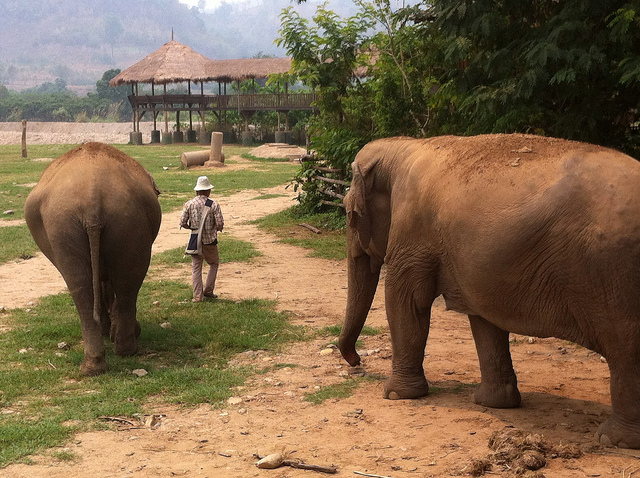What is between the elephants? Positioned between the elephants is a man, likely serving as a caretaker or guide for these magnificent creatures, forming a connection between human and animal. 